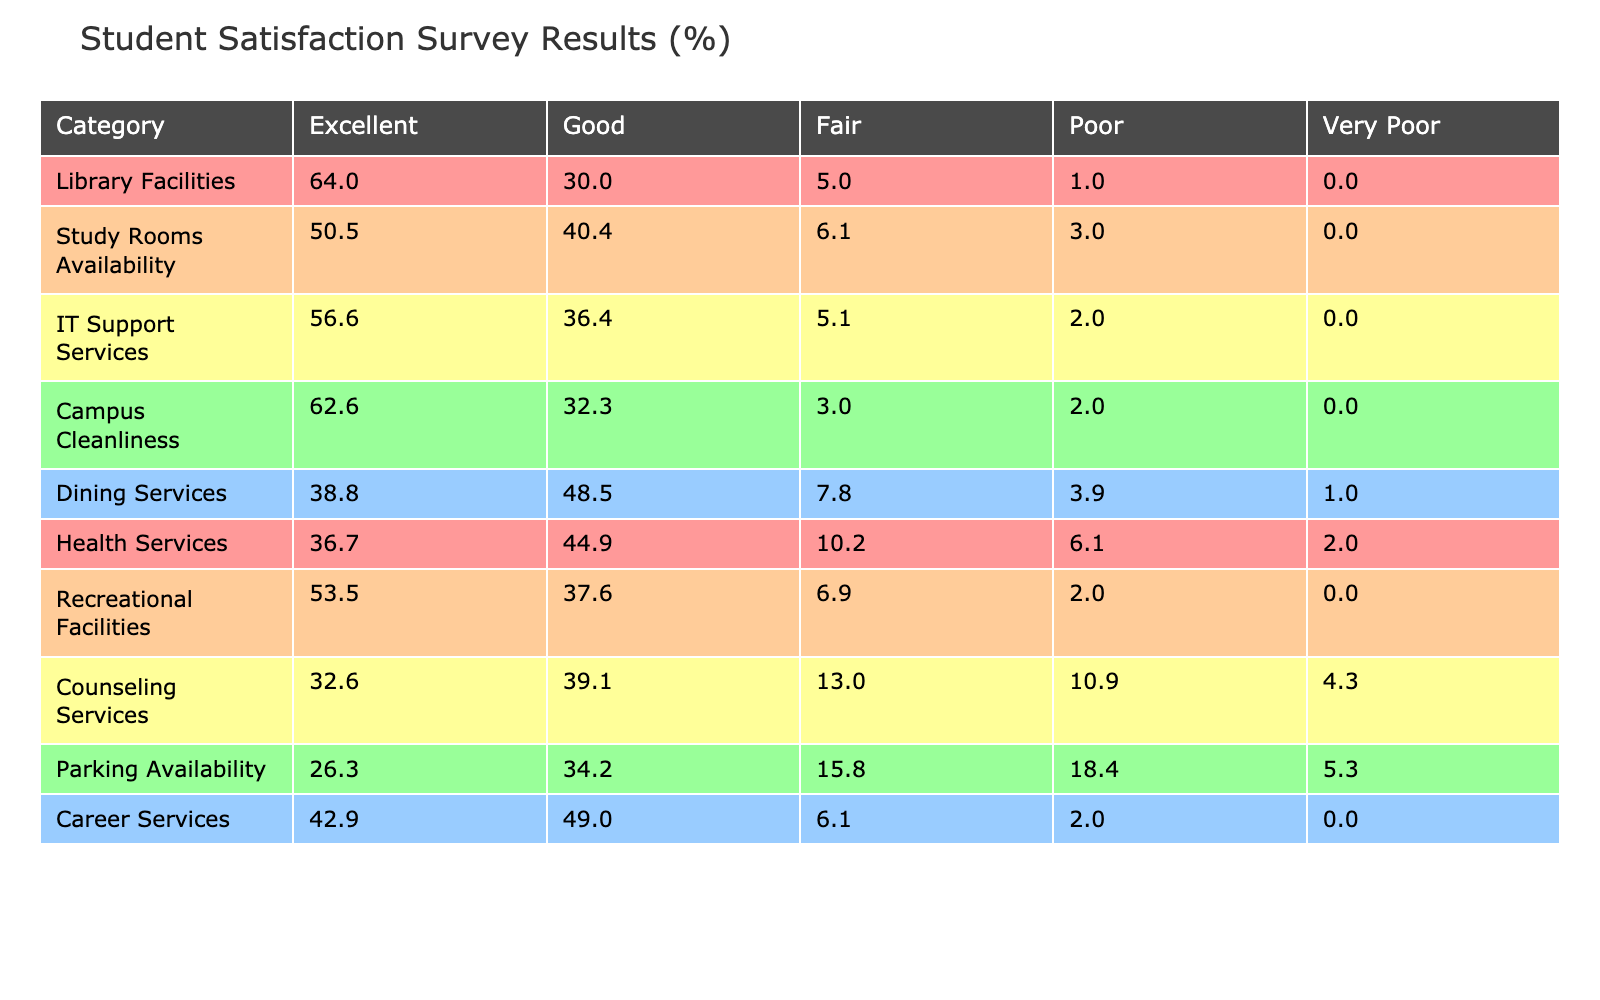What percentage of students rated the Library Facilities as Excellent? The table shows that 320 students rated the Library Facilities as Excellent. The total respondents for Library Facilities are 320 + 150 + 25 + 5 + 0 = 500. The percentage is (320/500) * 100 = 64.0%.
Answer: 64.0% What is the percentage of students who found the Health Services either Fair or Poor? The Health Services category has 50 students rating it Fair and 30 students rating it Poor, totaling 50 + 30 = 80. The total respondents for Health Services are 180 + 220 + 50 + 30 + 10 = 490. The percentage is (80/490) * 100 = 16.3%.
Answer: 16.3% Which category had the highest percentage of students rating it as Very Poor? From the table, Parking Availability has 20 students rating it as Very Poor, the highest among the categories. The total for Parking Availability is 100 + 130 + 60 + 70 + 20 = 380. The percentage is (20/380) * 100 = 5.3%.
Answer: Parking Availability Did more students rate Study Rooms Availability as Good than those who rated it as Fair? Study Rooms Availability had 200 students rating it as Good and 30 rating it as Fair. Since 200 is greater than 30, it is true that more students rated it as Good.
Answer: Yes What is the overall average satisfaction percentage across all categories for Excellent ratings? First, sum the Excellent ratings: 320 + 250 + 280 + 310 + 200 + 180 + 270 + 150 + 100 + 210 = 1970. The total across all categories is 5000. The average is 1970 / 10 = 197. To find the percentage, we divide by the total: (197 / 5000) * 100 = 39.4%.
Answer: 39.4% 